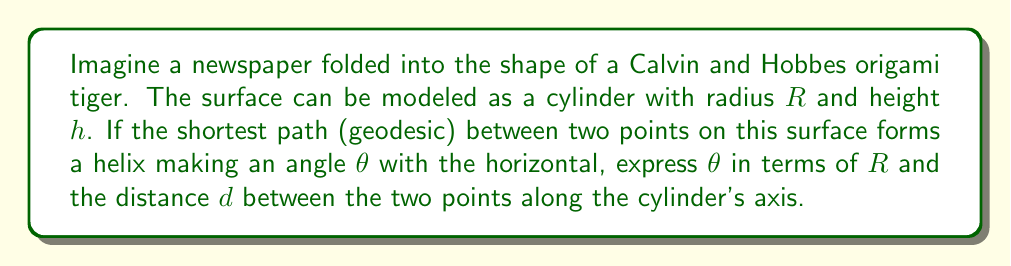Give your solution to this math problem. Let's approach this step-by-step:

1) In a cylinder, geodesics are helices (except for special cases like circles and straight lines).

2) Consider "unwrapping" the cylinder. The helix becomes a straight line on this flat surface.

3) Let the circumference of the cylinder be $C = 2\pi R$.

4) If we unwrap one complete turn of the helix, we get a right triangle:
   - The base of this triangle is $C = 2\pi R$
   - The height is $h$, the distance along the cylinder's axis
   - The hypotenuse is the length of one turn of the helix

5) Now, $\tan \theta = \frac{h}{2\pi R}$

6) But we're not necessarily dealing with a complete turn. We're dealing with a distance $d$ along the axis.

7) The ratio of $d$ to $h$ is the same as the ratio of the arc length $s$ (along the cylinder's surface) to $2\pi R$:

   $$\frac{d}{h} = \frac{s}{2\pi R}$$

8) From the properties of right triangles:

   $$\cos \theta = \frac{s}{l}$$

   where $l$ is the length of the geodesic.

9) Also:

   $$\sin \theta = \frac{d}{l}$$

10) Dividing these equations:

    $$\tan \theta = \frac{d}{s} = \frac{d}{2\pi R}$$

11) Therefore:

    $$\theta = \arctan(\frac{d}{2\pi R})$$
Answer: $\theta = \arctan(\frac{d}{2\pi R})$ 